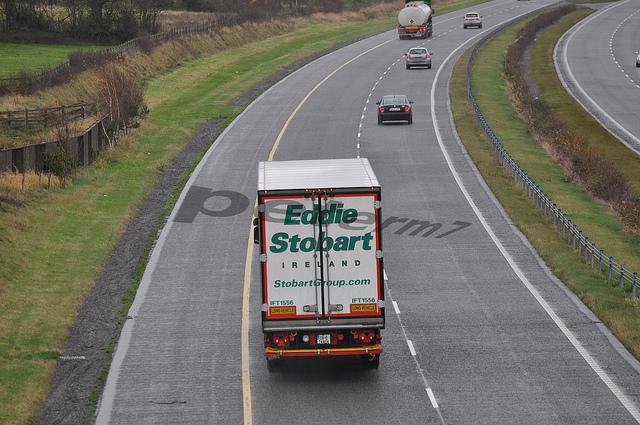What country name is on the truck?
Be succinct. Ireland. How many vehicles are not trucks?
Concise answer only. 3. Is this a truck of a moving company?
Write a very short answer. No. 